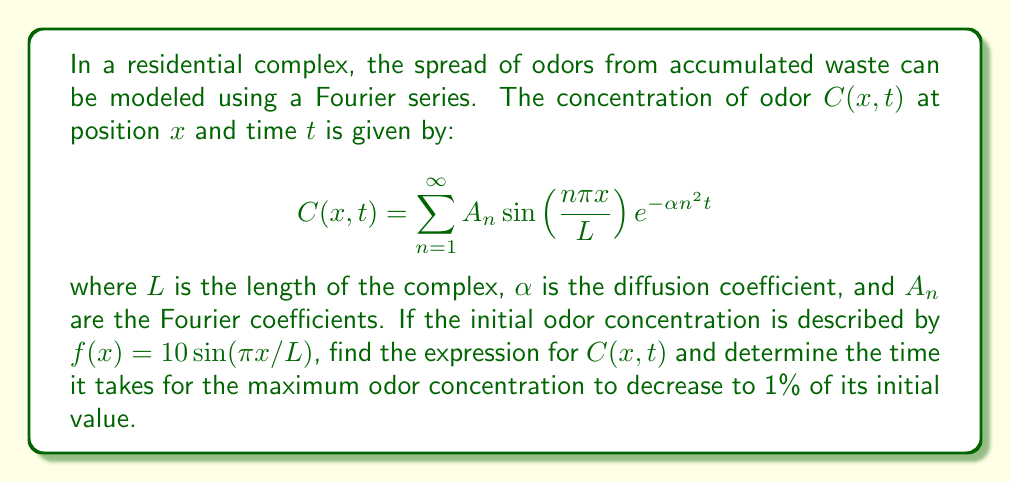What is the answer to this math problem? To solve this problem, we need to follow these steps:

1) First, we need to find the Fourier coefficients $A_n$. Given the initial condition $f(x) = 10\sin(\pi x/L)$, we can see that only $A_1 = 10$ and all other $A_n = 0$ for $n > 1$.

2) Therefore, our expression for $C(x,t)$ simplifies to:

   $$C(x,t) = 10 \sin\left(\frac{\pi x}{L}\right)e^{-\alpha \pi^2 t/L^2}$$

3) To find the time it takes for the maximum concentration to decrease to 1% of its initial value, we need to solve:

   $$e^{-\alpha \pi^2 t/L^2} = 0.01$$

4) Taking the natural logarithm of both sides:

   $$-\frac{\alpha \pi^2 t}{L^2} = \ln(0.01) = -4.605$$

5) Solving for $t$:

   $$t = \frac{4.605 L^2}{\alpha \pi^2}$$

This gives us the time it takes for the maximum concentration to decrease to 1% of its initial value, regardless of the position $x$.
Answer: The expression for $C(x,t)$ is:

$$C(x,t) = 10 \sin\left(\frac{\pi x}{L}\right)e^{-\alpha \pi^2 t/L^2}$$

The time it takes for the maximum odor concentration to decrease to 1% of its initial value is:

$$t = \frac{4.605 L^2}{\alpha \pi^2}$$ 